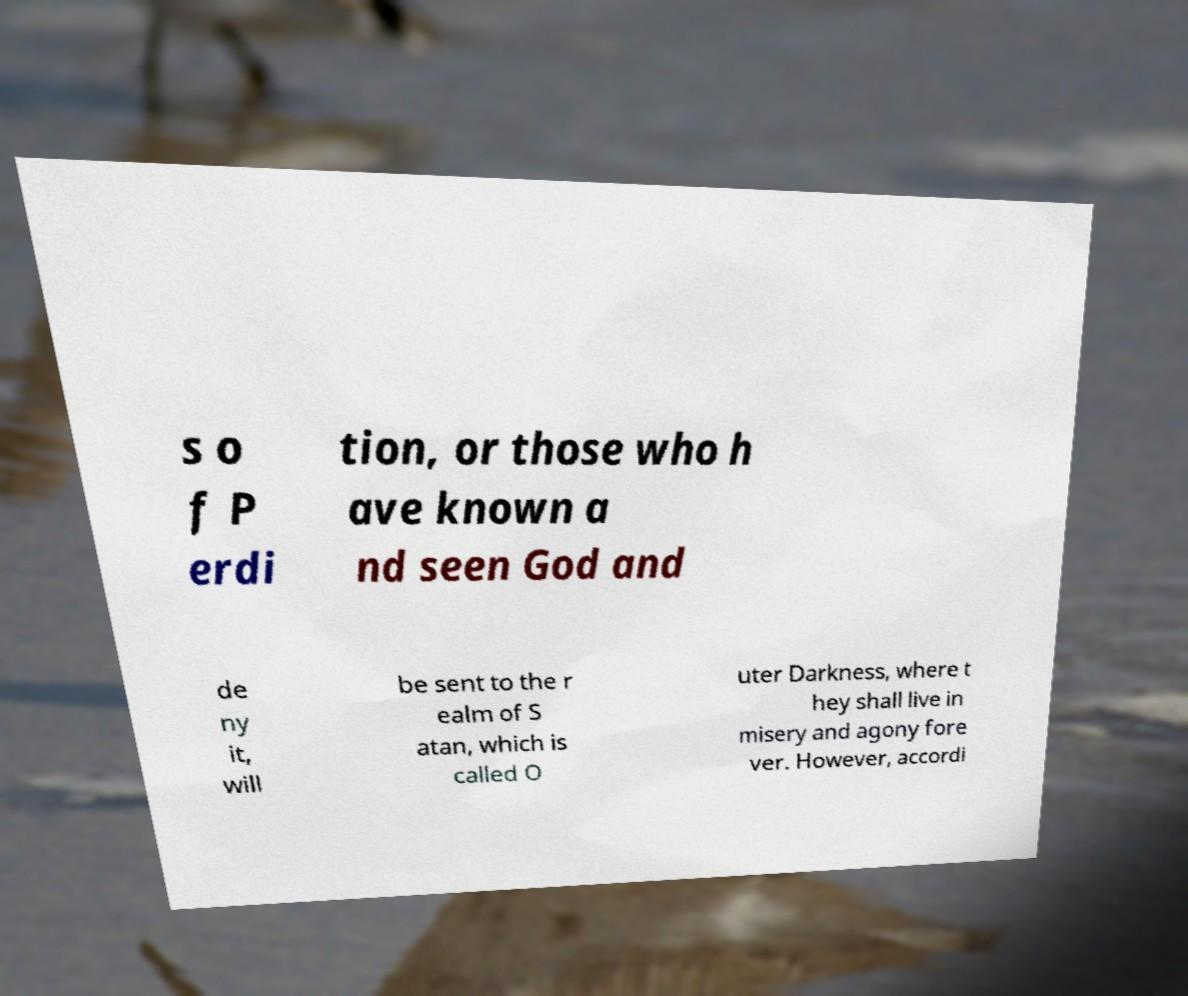Can you read and provide the text displayed in the image?This photo seems to have some interesting text. Can you extract and type it out for me? s o f P erdi tion, or those who h ave known a nd seen God and de ny it, will be sent to the r ealm of S atan, which is called O uter Darkness, where t hey shall live in misery and agony fore ver. However, accordi 